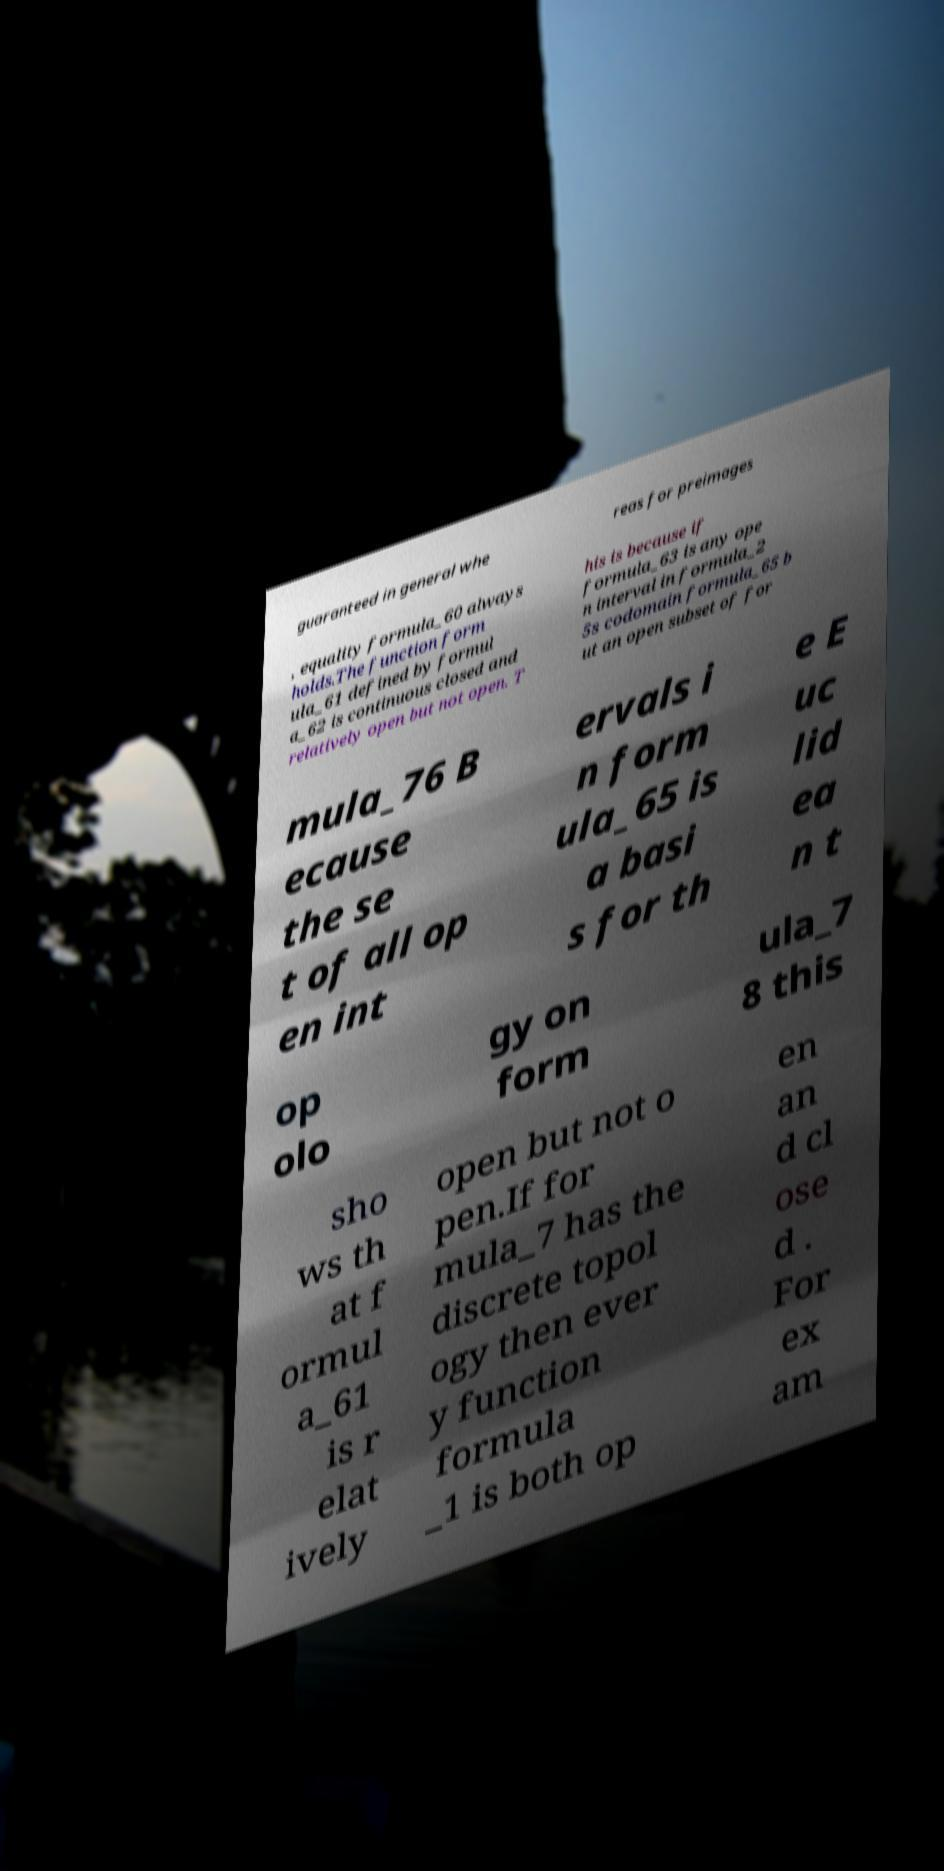What messages or text are displayed in this image? I need them in a readable, typed format. guaranteed in general whe reas for preimages , equality formula_60 always holds.The function form ula_61 defined by formul a_62 is continuous closed and relatively open but not open. T his is because if formula_63 is any ope n interval in formula_2 5s codomain formula_65 b ut an open subset of for mula_76 B ecause the se t of all op en int ervals i n form ula_65 is a basi s for th e E uc lid ea n t op olo gy on form ula_7 8 this sho ws th at f ormul a_61 is r elat ively open but not o pen.If for mula_7 has the discrete topol ogy then ever y function formula _1 is both op en an d cl ose d . For ex am 